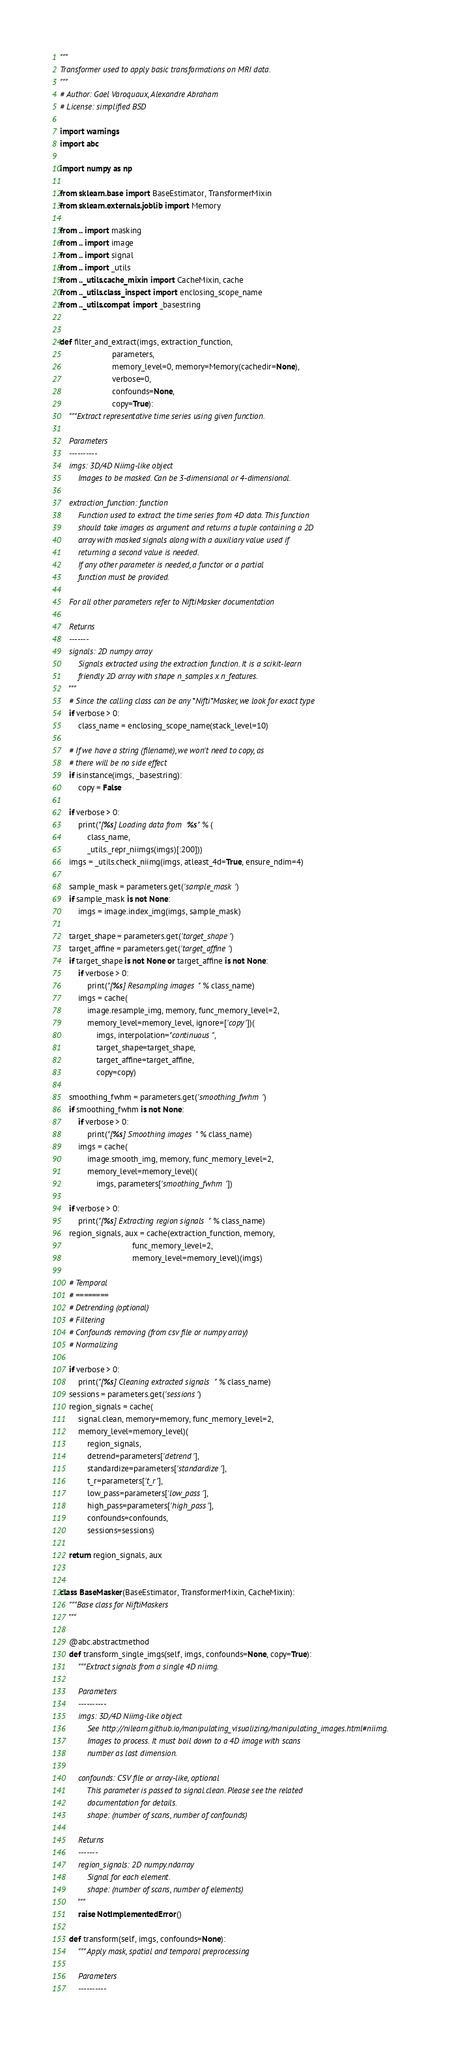Convert code to text. <code><loc_0><loc_0><loc_500><loc_500><_Python_>"""
Transformer used to apply basic transformations on MRI data.
"""
# Author: Gael Varoquaux, Alexandre Abraham
# License: simplified BSD

import warnings
import abc

import numpy as np

from sklearn.base import BaseEstimator, TransformerMixin
from sklearn.externals.joblib import Memory

from .. import masking
from .. import image
from .. import signal
from .. import _utils
from .._utils.cache_mixin import CacheMixin, cache
from .._utils.class_inspect import enclosing_scope_name
from .._utils.compat import _basestring


def filter_and_extract(imgs, extraction_function,
                       parameters,
                       memory_level=0, memory=Memory(cachedir=None),
                       verbose=0,
                       confounds=None,
                       copy=True):
    """Extract representative time series using given function.

    Parameters
    ----------
    imgs: 3D/4D Niimg-like object
        Images to be masked. Can be 3-dimensional or 4-dimensional.

    extraction_function: function
        Function used to extract the time series from 4D data. This function
        should take images as argument and returns a tuple containing a 2D
        array with masked signals along with a auxiliary value used if
        returning a second value is needed.
        If any other parameter is needed, a functor or a partial
        function must be provided.

    For all other parameters refer to NiftiMasker documentation

    Returns
    -------
    signals: 2D numpy array
        Signals extracted using the extraction function. It is a scikit-learn
        friendly 2D array with shape n_samples x n_features.
    """
    # Since the calling class can be any *Nifti*Masker, we look for exact type
    if verbose > 0:
        class_name = enclosing_scope_name(stack_level=10)

    # If we have a string (filename), we won't need to copy, as
    # there will be no side effect
    if isinstance(imgs, _basestring):
        copy = False

    if verbose > 0:
        print("[%s] Loading data from %s" % (
            class_name,
            _utils._repr_niimgs(imgs)[:200]))
    imgs = _utils.check_niimg(imgs, atleast_4d=True, ensure_ndim=4)

    sample_mask = parameters.get('sample_mask')
    if sample_mask is not None:
        imgs = image.index_img(imgs, sample_mask)

    target_shape = parameters.get('target_shape')
    target_affine = parameters.get('target_affine')
    if target_shape is not None or target_affine is not None:
        if verbose > 0:
            print("[%s] Resampling images" % class_name)
        imgs = cache(
            image.resample_img, memory, func_memory_level=2,
            memory_level=memory_level, ignore=['copy'])(
                imgs, interpolation="continuous",
                target_shape=target_shape,
                target_affine=target_affine,
                copy=copy)

    smoothing_fwhm = parameters.get('smoothing_fwhm')
    if smoothing_fwhm is not None:
        if verbose > 0:
            print("[%s] Smoothing images" % class_name)
        imgs = cache(
            image.smooth_img, memory, func_memory_level=2,
            memory_level=memory_level)(
                imgs, parameters['smoothing_fwhm'])

    if verbose > 0:
        print("[%s] Extracting region signals" % class_name)
    region_signals, aux = cache(extraction_function, memory,
                                func_memory_level=2,
                                memory_level=memory_level)(imgs)

    # Temporal
    # ========
    # Detrending (optional)
    # Filtering
    # Confounds removing (from csv file or numpy array)
    # Normalizing

    if verbose > 0:
        print("[%s] Cleaning extracted signals" % class_name)
    sessions = parameters.get('sessions')
    region_signals = cache(
        signal.clean, memory=memory, func_memory_level=2,
        memory_level=memory_level)(
            region_signals,
            detrend=parameters['detrend'],
            standardize=parameters['standardize'],
            t_r=parameters['t_r'],
            low_pass=parameters['low_pass'],
            high_pass=parameters['high_pass'],
            confounds=confounds,
            sessions=sessions)

    return region_signals, aux


class BaseMasker(BaseEstimator, TransformerMixin, CacheMixin):
    """Base class for NiftiMaskers
    """

    @abc.abstractmethod
    def transform_single_imgs(self, imgs, confounds=None, copy=True):
        """Extract signals from a single 4D niimg.

        Parameters
        ----------
        imgs: 3D/4D Niimg-like object
            See http://nilearn.github.io/manipulating_visualizing/manipulating_images.html#niimg.
            Images to process. It must boil down to a 4D image with scans
            number as last dimension.

        confounds: CSV file or array-like, optional
            This parameter is passed to signal.clean. Please see the related
            documentation for details.
            shape: (number of scans, number of confounds)

        Returns
        -------
        region_signals: 2D numpy.ndarray
            Signal for each element.
            shape: (number of scans, number of elements)
        """
        raise NotImplementedError()

    def transform(self, imgs, confounds=None):
        """Apply mask, spatial and temporal preprocessing

        Parameters
        ----------</code> 